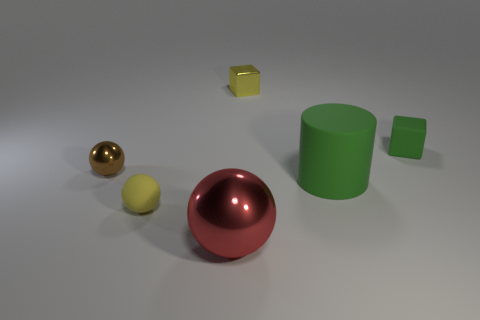There is a yellow thing that is behind the tiny ball in front of the cylinder; how big is it?
Offer a very short reply. Small. Is the number of tiny blocks that are right of the large red sphere the same as the number of yellow objects behind the small brown thing?
Provide a short and direct response. No. Are there any other things that are the same size as the brown sphere?
Make the answer very short. Yes. What is the color of the big ball that is made of the same material as the yellow cube?
Your answer should be very brief. Red. Do the yellow cube and the large object on the right side of the red thing have the same material?
Offer a terse response. No. What color is the thing that is to the left of the red shiny sphere and behind the large green matte cylinder?
Keep it short and to the point. Brown. What number of balls are either yellow things or green objects?
Your response must be concise. 1. There is a large green rubber object; is it the same shape as the small yellow object that is behind the brown thing?
Offer a terse response. No. How big is the shiny object that is on the right side of the tiny rubber sphere and behind the green cylinder?
Provide a succinct answer. Small. What is the shape of the big green thing?
Provide a succinct answer. Cylinder. 